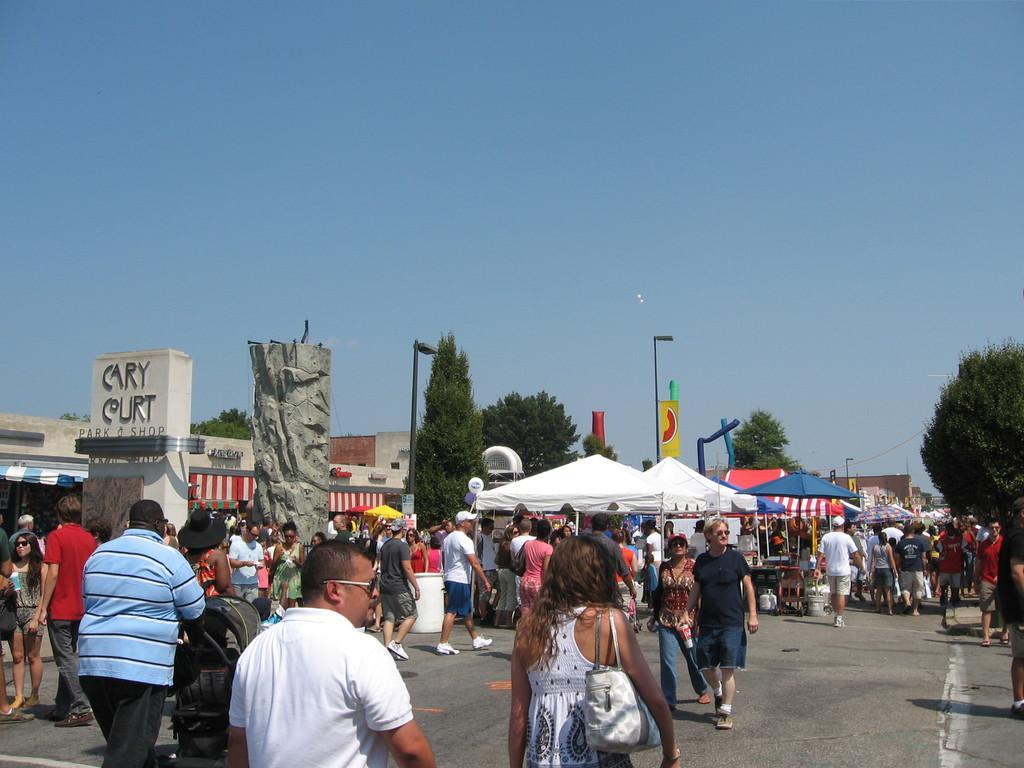Could you give a brief overview of what you see in this image? In the center of the image there are many people walking on the road. There are stalls. There are trees. There is a light pole. At the top of the image there is sky. 